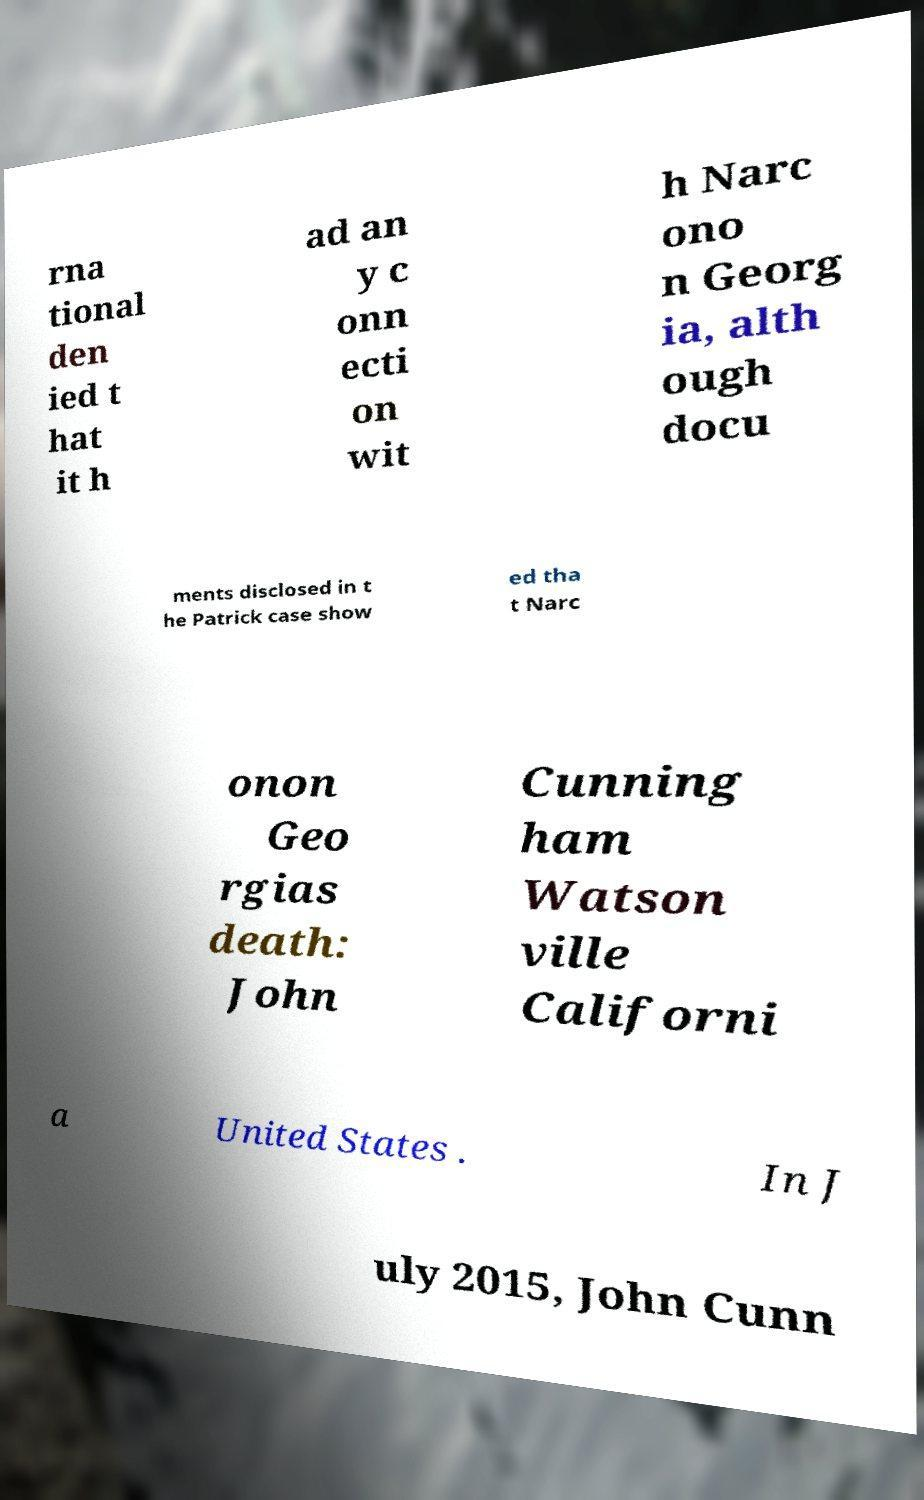There's text embedded in this image that I need extracted. Can you transcribe it verbatim? rna tional den ied t hat it h ad an y c onn ecti on wit h Narc ono n Georg ia, alth ough docu ments disclosed in t he Patrick case show ed tha t Narc onon Geo rgias death: John Cunning ham Watson ville Californi a United States . In J uly 2015, John Cunn 